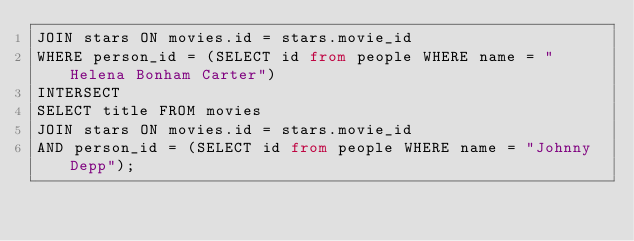<code> <loc_0><loc_0><loc_500><loc_500><_SQL_>JOIN stars ON movies.id = stars.movie_id
WHERE person_id = (SELECT id from people WHERE name = "Helena Bonham Carter")
INTERSECT
SELECT title FROM movies
JOIN stars ON movies.id = stars.movie_id
AND person_id = (SELECT id from people WHERE name = "Johnny Depp");</code> 